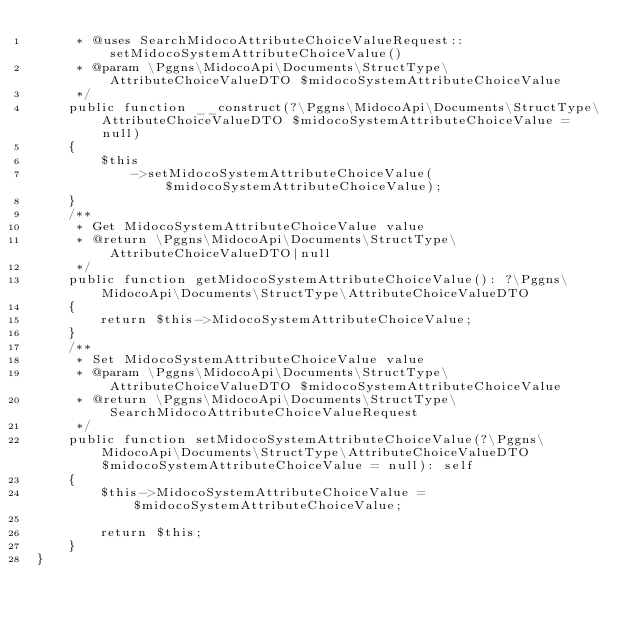<code> <loc_0><loc_0><loc_500><loc_500><_PHP_>     * @uses SearchMidocoAttributeChoiceValueRequest::setMidocoSystemAttributeChoiceValue()
     * @param \Pggns\MidocoApi\Documents\StructType\AttributeChoiceValueDTO $midocoSystemAttributeChoiceValue
     */
    public function __construct(?\Pggns\MidocoApi\Documents\StructType\AttributeChoiceValueDTO $midocoSystemAttributeChoiceValue = null)
    {
        $this
            ->setMidocoSystemAttributeChoiceValue($midocoSystemAttributeChoiceValue);
    }
    /**
     * Get MidocoSystemAttributeChoiceValue value
     * @return \Pggns\MidocoApi\Documents\StructType\AttributeChoiceValueDTO|null
     */
    public function getMidocoSystemAttributeChoiceValue(): ?\Pggns\MidocoApi\Documents\StructType\AttributeChoiceValueDTO
    {
        return $this->MidocoSystemAttributeChoiceValue;
    }
    /**
     * Set MidocoSystemAttributeChoiceValue value
     * @param \Pggns\MidocoApi\Documents\StructType\AttributeChoiceValueDTO $midocoSystemAttributeChoiceValue
     * @return \Pggns\MidocoApi\Documents\StructType\SearchMidocoAttributeChoiceValueRequest
     */
    public function setMidocoSystemAttributeChoiceValue(?\Pggns\MidocoApi\Documents\StructType\AttributeChoiceValueDTO $midocoSystemAttributeChoiceValue = null): self
    {
        $this->MidocoSystemAttributeChoiceValue = $midocoSystemAttributeChoiceValue;
        
        return $this;
    }
}
</code> 